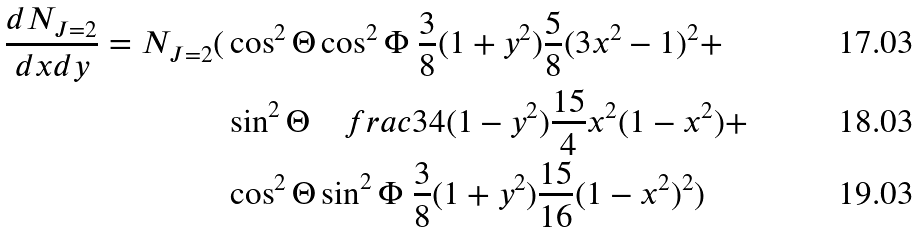<formula> <loc_0><loc_0><loc_500><loc_500>\frac { d N _ { J = 2 } } { d x d y } = N _ { J = 2 } ( & \cos ^ { 2 } \Theta \cos ^ { 2 } \Phi \ \frac { 3 } { 8 } ( 1 + y ^ { 2 } ) \frac { 5 } { 8 } ( 3 x ^ { 2 } - 1 ) ^ { 2 } + \\ & \sin ^ { 2 } \Theta \quad f r a c { 3 } { 4 } ( 1 - y ^ { 2 } ) \frac { 1 5 } { 4 } x ^ { 2 } ( 1 - x ^ { 2 } ) + \\ & \cos ^ { 2 } \Theta \sin ^ { 2 } \Phi \ \frac { 3 } { 8 } ( 1 + y ^ { 2 } ) \frac { 1 5 } { 1 6 } ( 1 - x ^ { 2 } ) ^ { 2 } )</formula> 